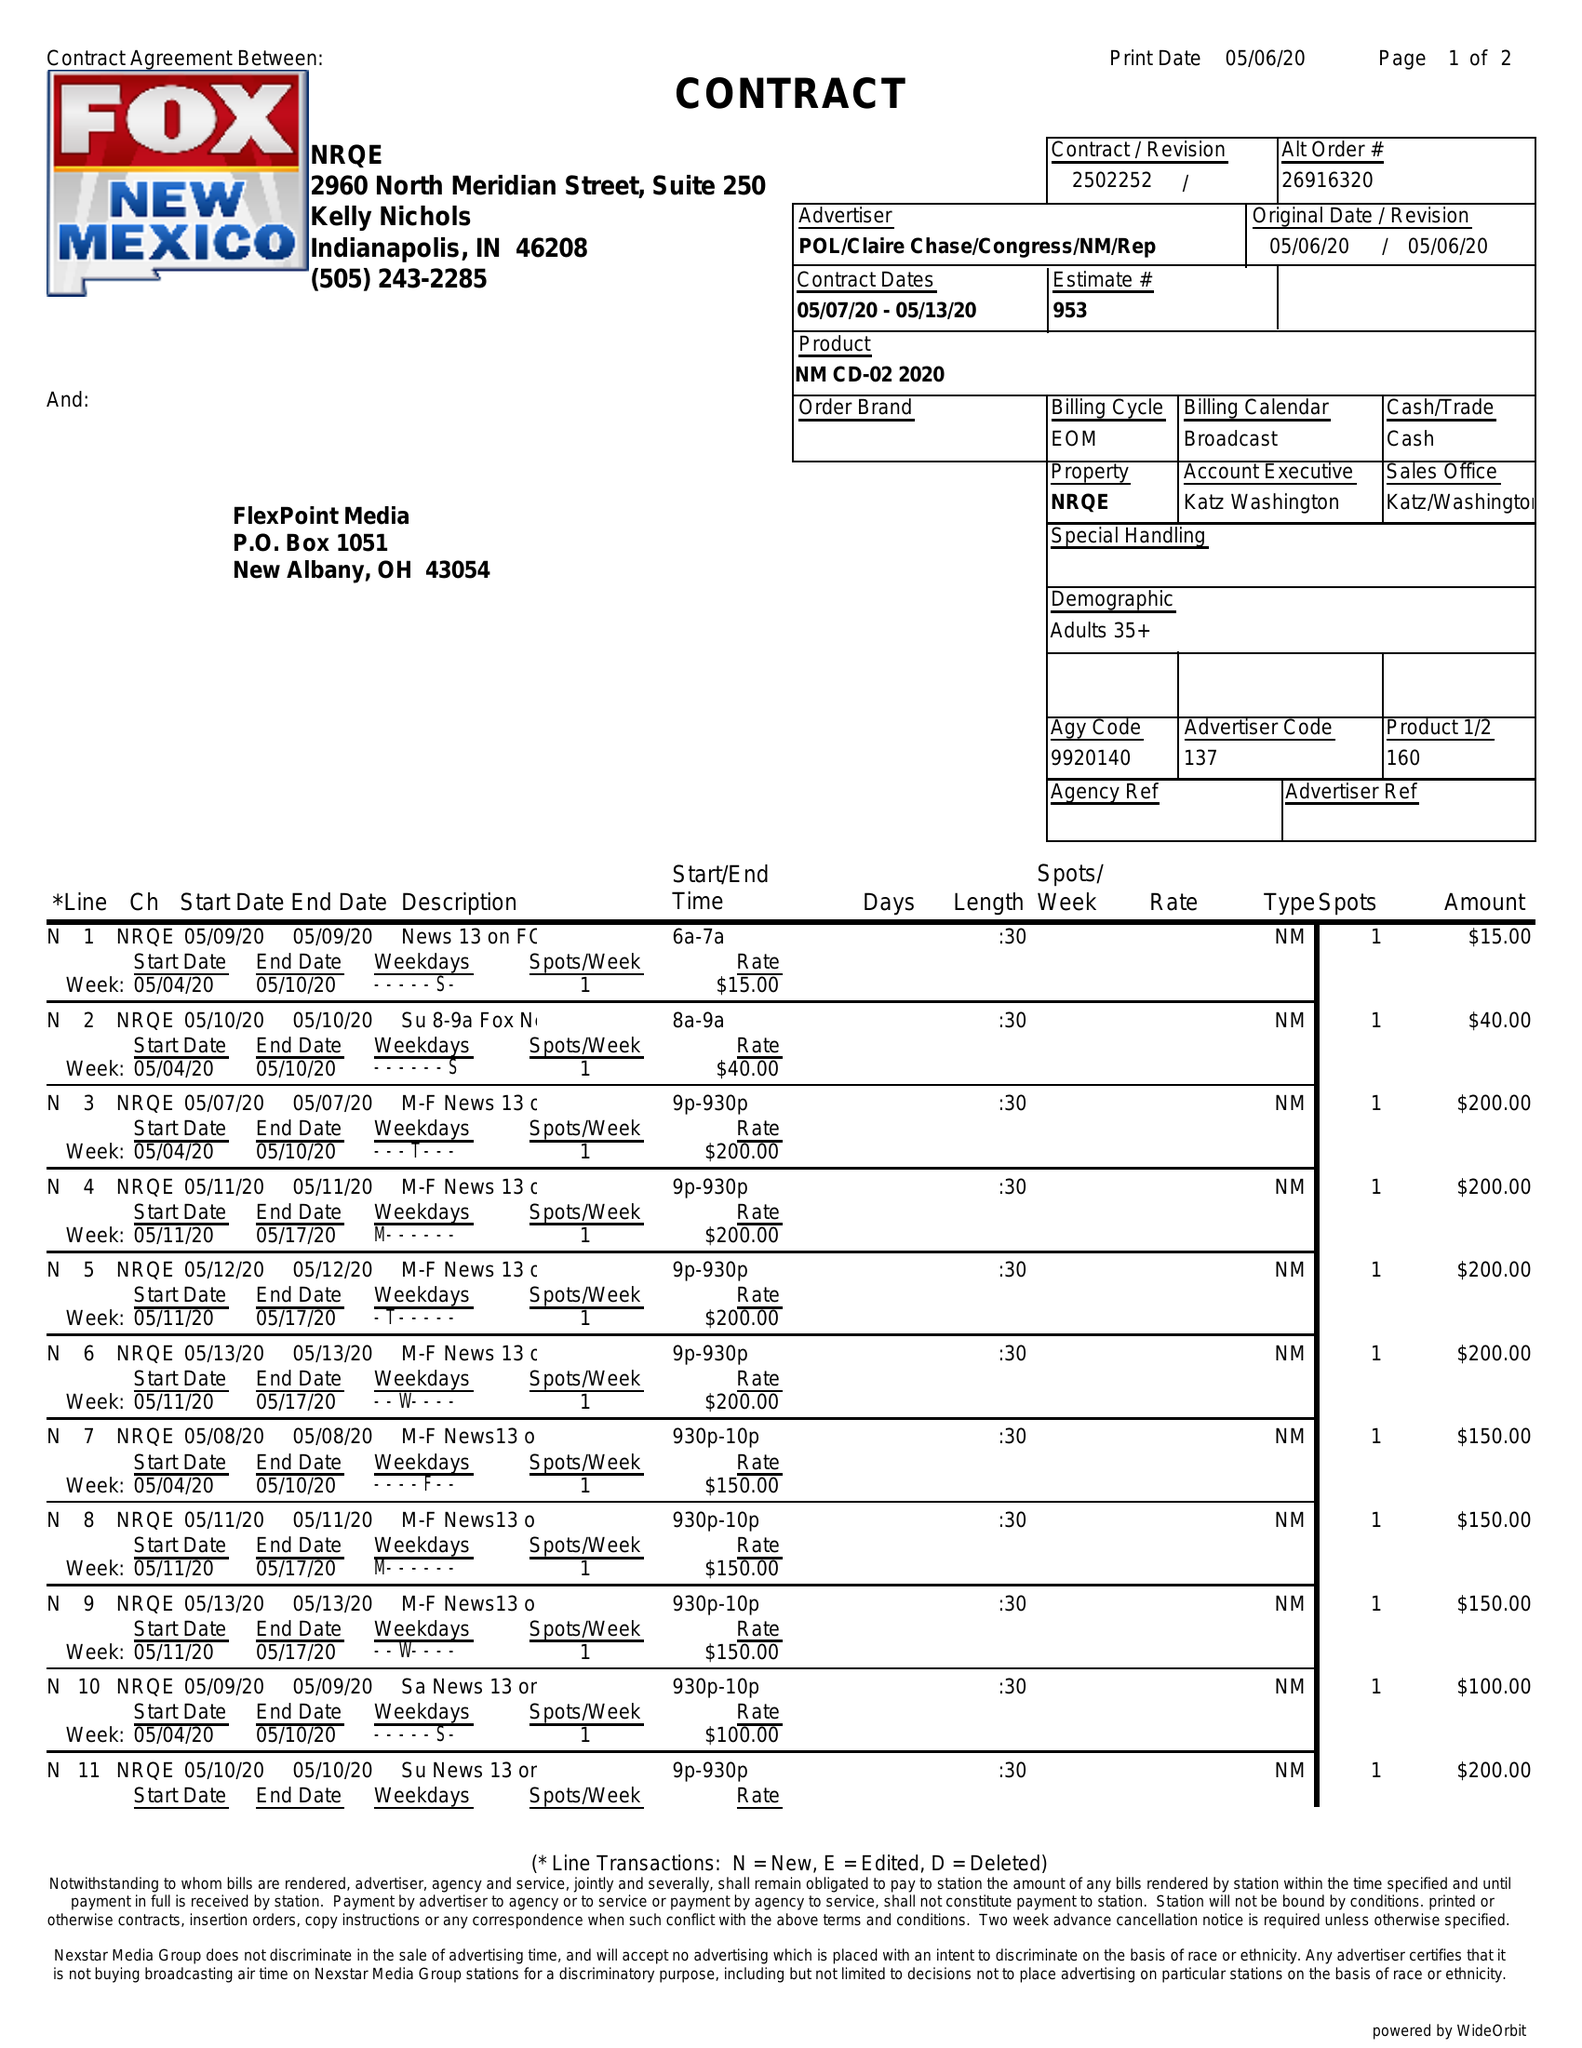What is the value for the flight_from?
Answer the question using a single word or phrase. 05/07/20 